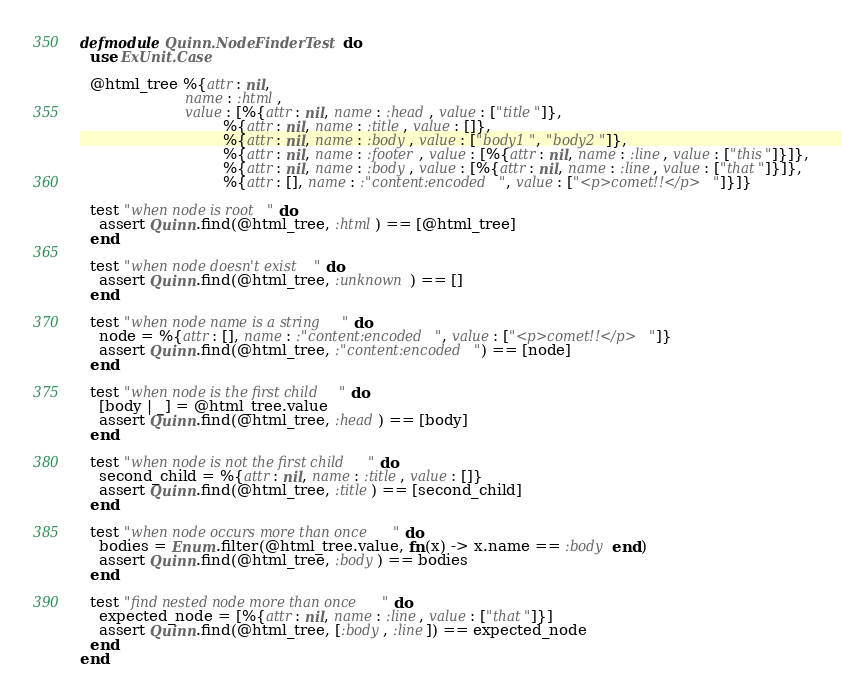Convert code to text. <code><loc_0><loc_0><loc_500><loc_500><_Elixir_>defmodule Quinn.NodeFinderTest do
  use ExUnit.Case

  @html_tree %{attr: nil,
                      name: :html,
                      value: [%{attr: nil, name: :head, value: ["title"]},
                              %{attr: nil, name: :title, value: []},
                              %{attr: nil, name: :body, value: ["body1", "body2"]},
                              %{attr: nil, name: :footer, value: [%{attr: nil, name: :line, value: ["this"]}]},
                              %{attr: nil, name: :body, value: [%{attr: nil, name: :line, value: ["that"]}]},
                              %{attr: [], name: :"content:encoded", value: ["<p>comet!!</p>"]}]}

  test "when node is root" do
    assert Quinn.find(@html_tree, :html) == [@html_tree]
  end

  test "when node doesn't exist" do
    assert Quinn.find(@html_tree, :unknown) == []
  end

  test "when node name is a string" do
    node = %{attr: [], name: :"content:encoded", value: ["<p>comet!!</p>"]}
    assert Quinn.find(@html_tree, :"content:encoded") == [node]
  end

  test "when node is the first child" do
    [body | _] = @html_tree.value
    assert Quinn.find(@html_tree, :head) == [body]
  end

  test "when node is not the first child" do
    second_child = %{attr: nil, name: :title, value: []}
    assert Quinn.find(@html_tree, :title) == [second_child]
  end

  test "when node occurs more than once" do
    bodies = Enum.filter(@html_tree.value, fn(x) -> x.name == :body end)
    assert Quinn.find(@html_tree, :body) == bodies
  end

  test "find nested node more than once" do
    expected_node = [%{attr: nil, name: :line, value: ["that"]}]
    assert Quinn.find(@html_tree, [:body, :line]) == expected_node
  end
end
</code> 